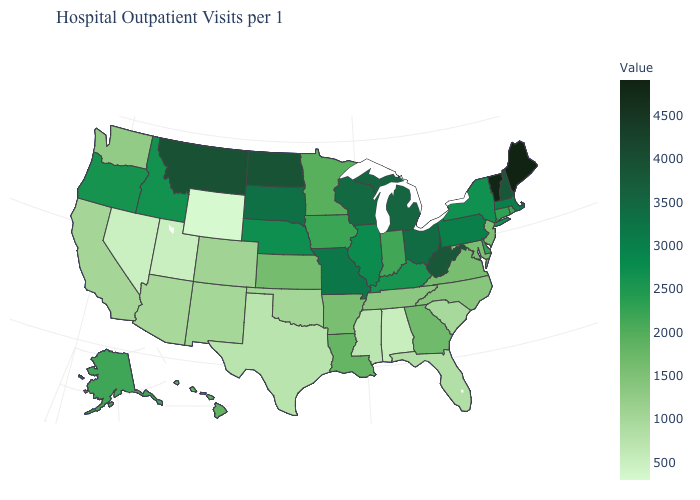Among the states that border New Hampshire , which have the lowest value?
Give a very brief answer. Massachusetts. Among the states that border New Jersey , which have the highest value?
Quick response, please. Pennsylvania. 